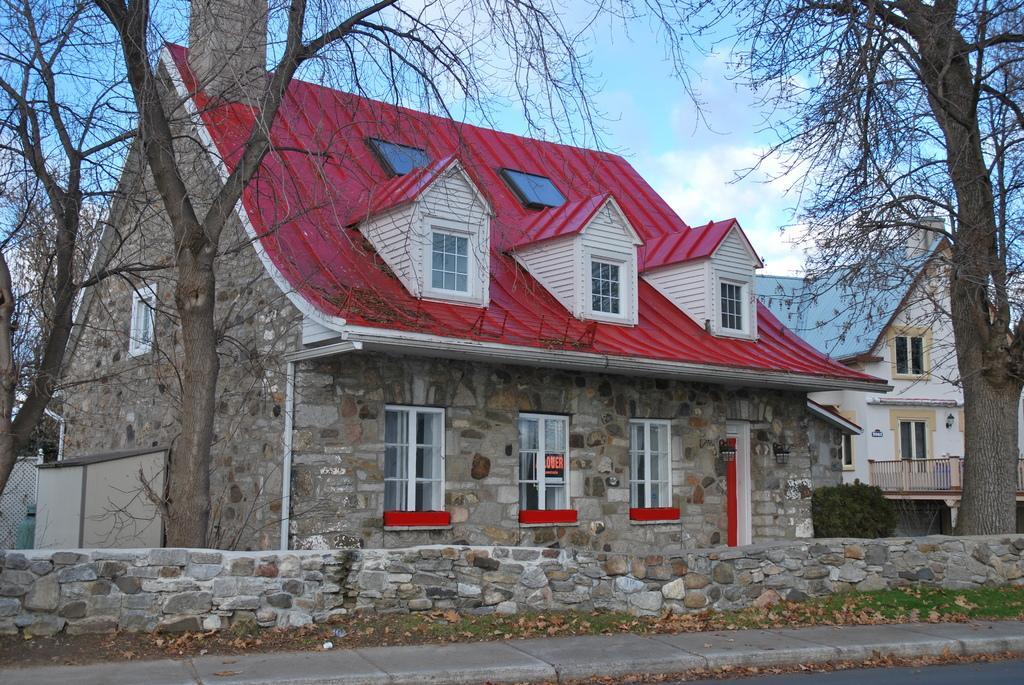Describe this image in one or two sentences. This picture is clicked outside. In the foreground we can see the stone wall and some portion of green grass and we can see the dry stems. In the center we can see the houses and some other items and we can see the plants. In the background we can see the sky. 